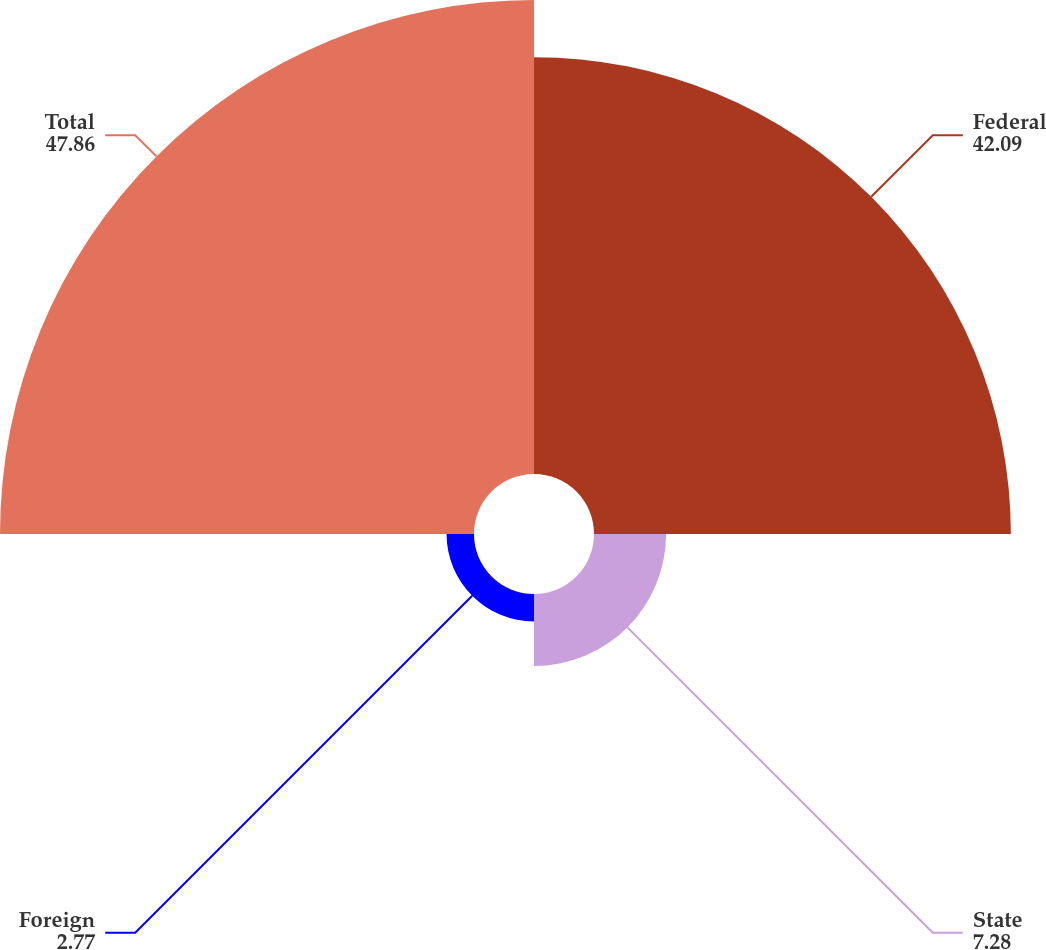Convert chart. <chart><loc_0><loc_0><loc_500><loc_500><pie_chart><fcel>Federal<fcel>State<fcel>Foreign<fcel>Total<nl><fcel>42.09%<fcel>7.28%<fcel>2.77%<fcel>47.86%<nl></chart> 